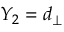<formula> <loc_0><loc_0><loc_500><loc_500>Y _ { 2 } = d _ { \perp }</formula> 